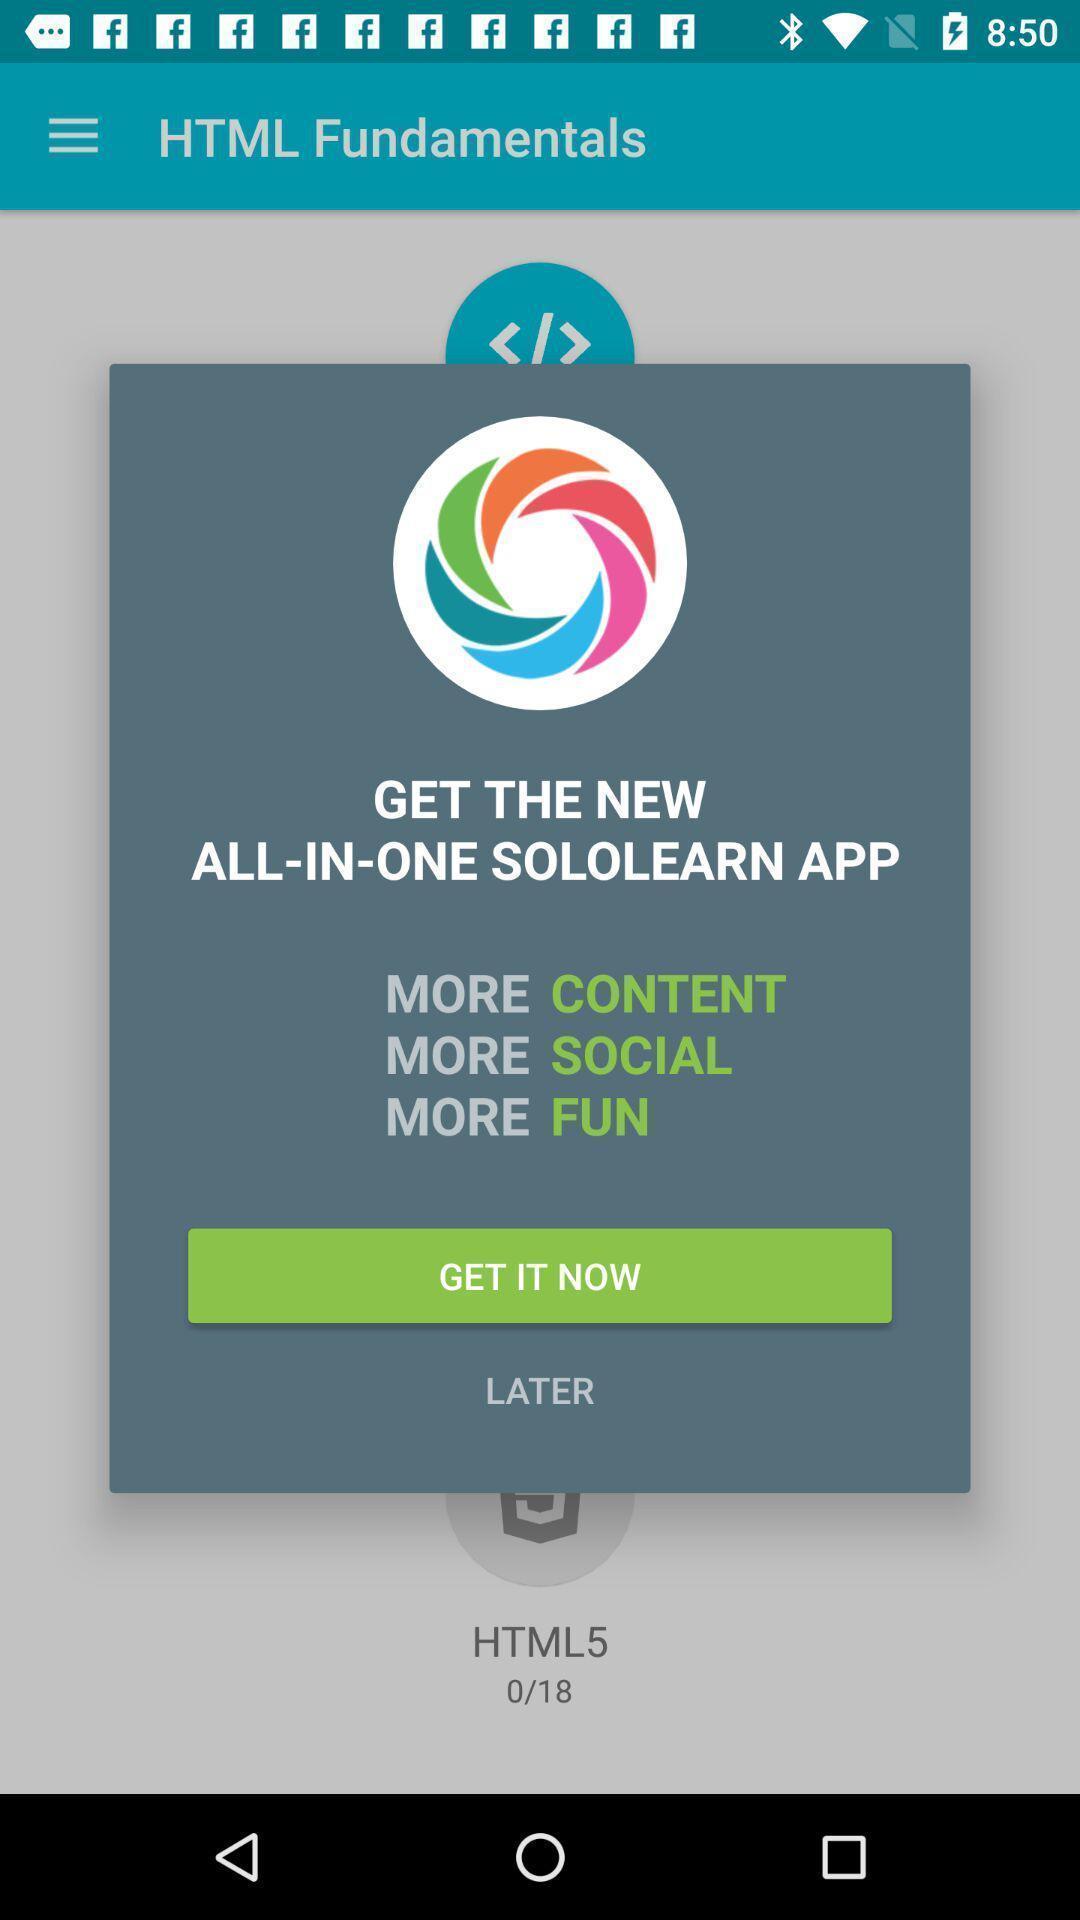Provide a textual representation of this image. Popup showing information about app. 